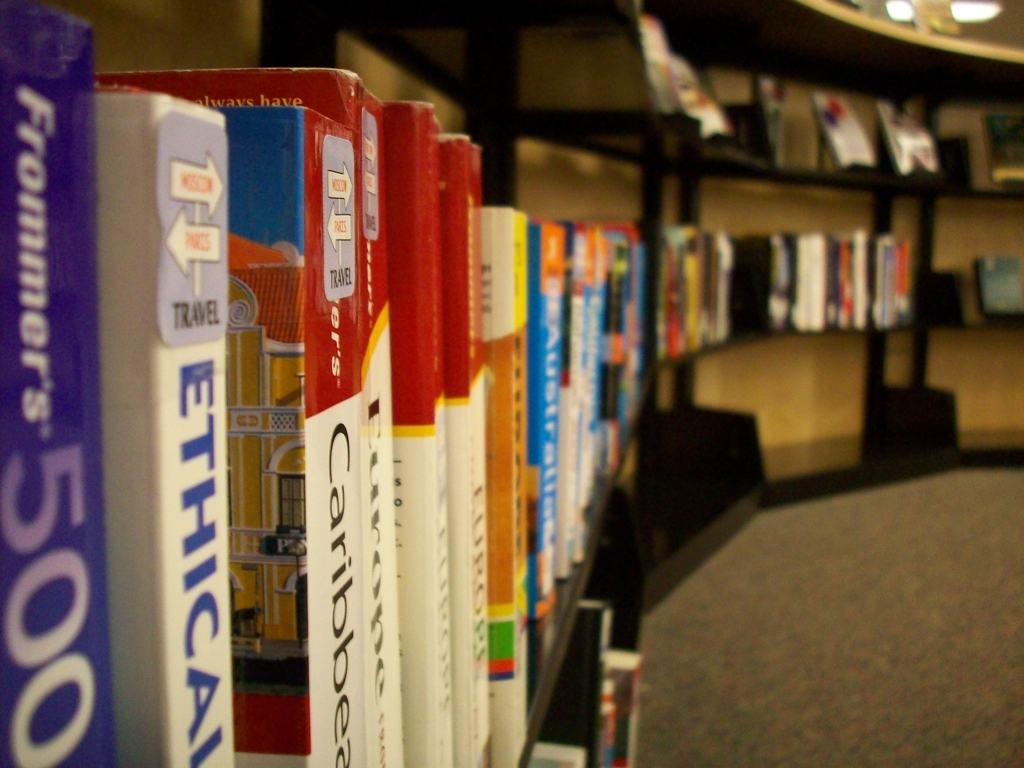Can you tell if the setting is public or private? The setting appears to be a public space, likely a library or a bookshop given the organized shelving and volume of books displayed for easy browsing. The lighting and the carpeted floor also suggest a maintained environment that caters to visitors. 